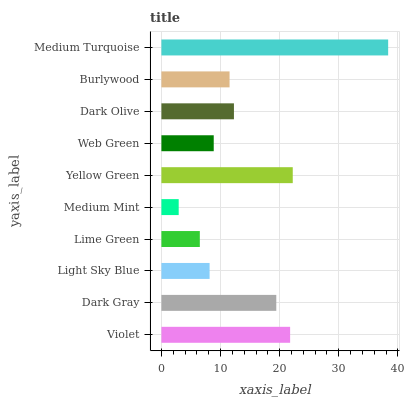Is Medium Mint the minimum?
Answer yes or no. Yes. Is Medium Turquoise the maximum?
Answer yes or no. Yes. Is Dark Gray the minimum?
Answer yes or no. No. Is Dark Gray the maximum?
Answer yes or no. No. Is Violet greater than Dark Gray?
Answer yes or no. Yes. Is Dark Gray less than Violet?
Answer yes or no. Yes. Is Dark Gray greater than Violet?
Answer yes or no. No. Is Violet less than Dark Gray?
Answer yes or no. No. Is Dark Olive the high median?
Answer yes or no. Yes. Is Burlywood the low median?
Answer yes or no. Yes. Is Violet the high median?
Answer yes or no. No. Is Lime Green the low median?
Answer yes or no. No. 